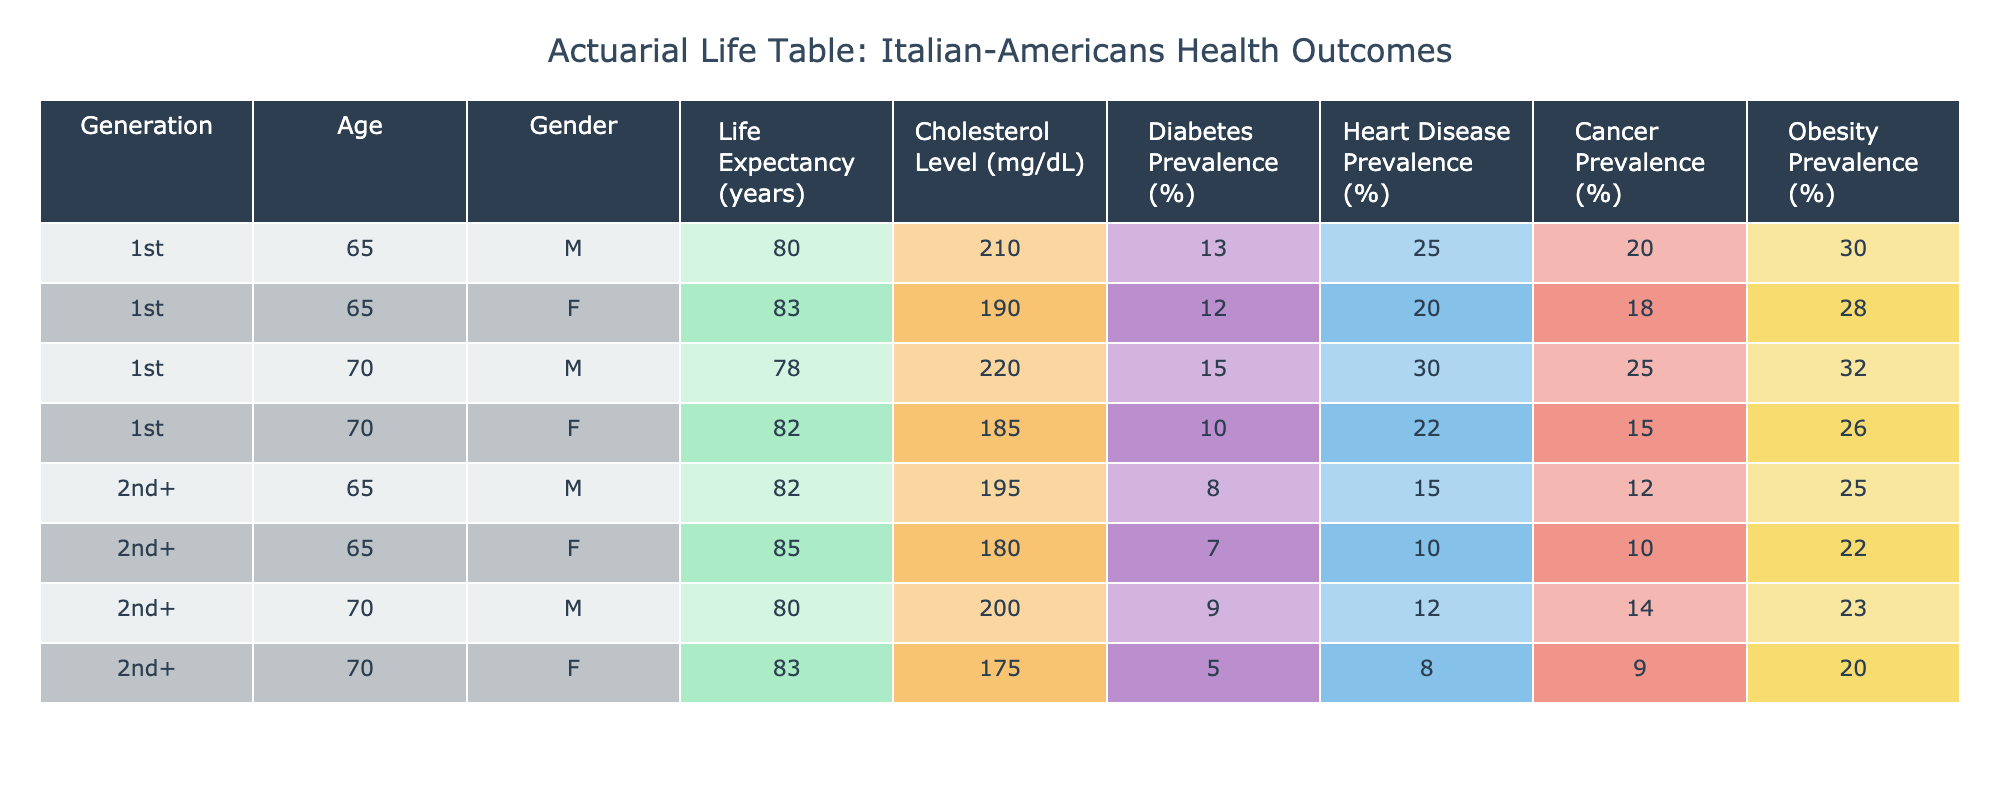What is the life expectancy for first-generation females at age 65? The table shows that the life expectancy for first-generation females at age 65 is 83 years.
Answer: 83 What is the cholesterol level for the later-generation males at age 70? According to the table, the cholesterol level for later-generation males at age 70 is 200 mg/dL.
Answer: 200 Which generation has a higher prevalence of diabetes among males aged 65? For males aged 65, first-generation has a diabetes prevalence of 13% while later-generation has only 8%. Therefore, first-generation has a higher prevalence.
Answer: Yes What is the average life expectancy for females across both generations at age 70? The life expectancy for first-generation females at age 70 is 82 years and for later-generation females at the same age, it’s 83 years. The average is (82 + 83) / 2 = 82.5 years.
Answer: 82.5 Are there any females from the first generation that have a higher cholesterol level than the males from the later generation? In the first generation, the cholesterol level for females is 190 mg/dL, while for males in the later generation it is 195 mg/dL. Thus, no females from the first generation have a higher cholesterol level than later generation males.
Answer: No What is the difference in cancer prevalence between the two generations for females at age 65? The cancer prevalence for first-generation females at age 65 is 18%, and for later-generation females at the same age, it is 10%. The difference is 18 - 10 = 8%.
Answer: 8% What is the overall trend in obesity prevalence from first-generation to later-generation among males aged 65? For males aged 65, first-generation has an obesity prevalence of 30%, while later-generation has 25%. This indicates a decreasing trend in obesity prevalence among males from first-generation to later-generation.
Answer: Decreasing What is the highest cholesterol level recorded in the table? The highest cholesterol level is found in the first-generation males at age 70, which is 220 mg/dL.
Answer: 220 Which generation shows a lower prevalence of heart disease at age 65, and by how much? First-generation males have a heart disease prevalence of 25%, while later-generation males have it at 15%. The difference is 25 - 15 = 10%. Hence, later-generation shows a lower prevalence of heart disease by 10%.
Answer: 10% 